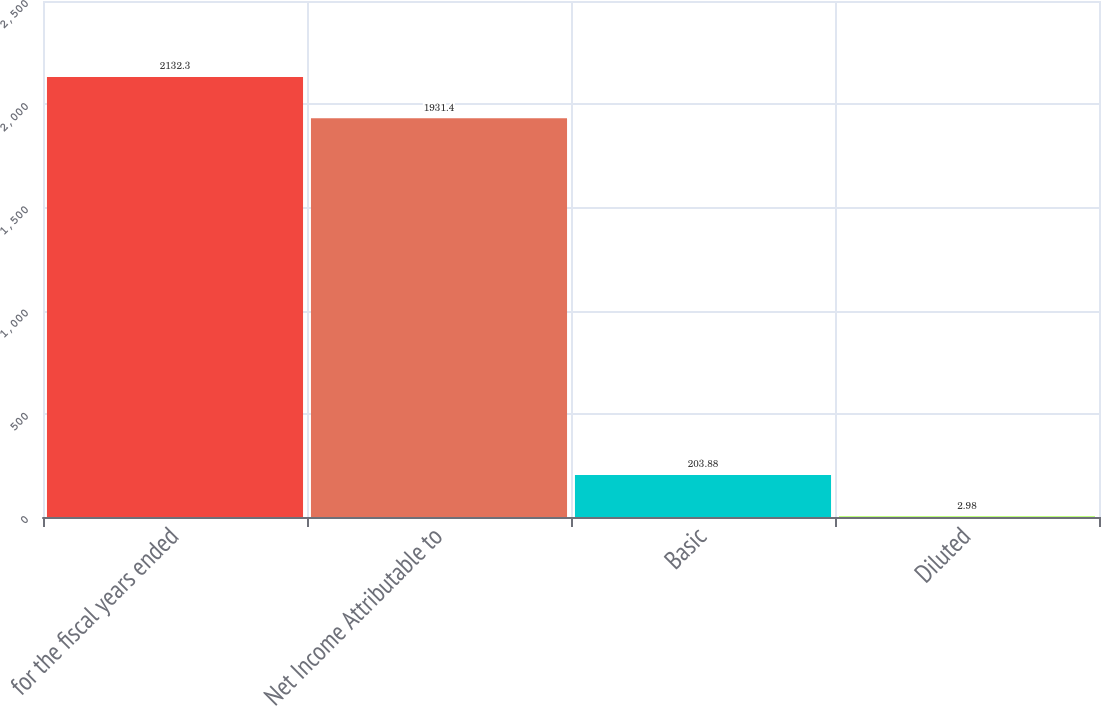Convert chart. <chart><loc_0><loc_0><loc_500><loc_500><bar_chart><fcel>for the fiscal years ended<fcel>Net Income Attributable to<fcel>Basic<fcel>Diluted<nl><fcel>2132.3<fcel>1931.4<fcel>203.88<fcel>2.98<nl></chart> 